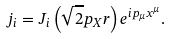<formula> <loc_0><loc_0><loc_500><loc_500>j _ { i } = J _ { i } \left ( \sqrt { 2 } p _ { X } r \right ) e ^ { i p _ { \mu } x ^ { \mu } } .</formula> 